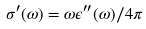Convert formula to latex. <formula><loc_0><loc_0><loc_500><loc_500>\sigma ^ { \prime } ( \omega ) = \omega \epsilon ^ { \prime \prime } ( \omega ) / 4 \pi</formula> 